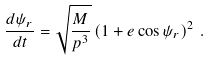<formula> <loc_0><loc_0><loc_500><loc_500>\frac { d \psi _ { r } } { d t } = \sqrt { \frac { M } { p ^ { 3 } } } \left ( 1 + e \cos \psi _ { r } \right ) ^ { 2 } \, .</formula> 